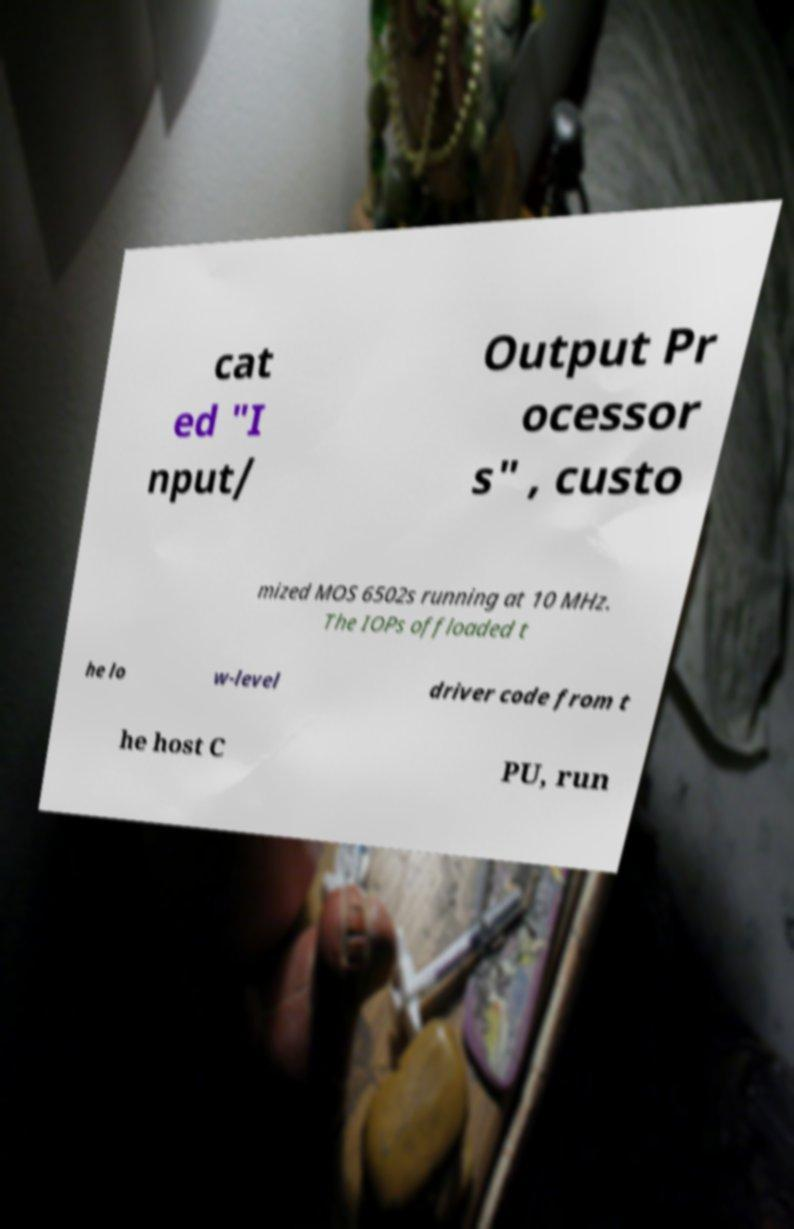For documentation purposes, I need the text within this image transcribed. Could you provide that? cat ed "I nput/ Output Pr ocessor s" , custo mized MOS 6502s running at 10 MHz. The IOPs offloaded t he lo w-level driver code from t he host C PU, run 